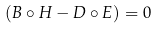<formula> <loc_0><loc_0><loc_500><loc_500>( B \circ H - D \circ E ) = 0 \,</formula> 